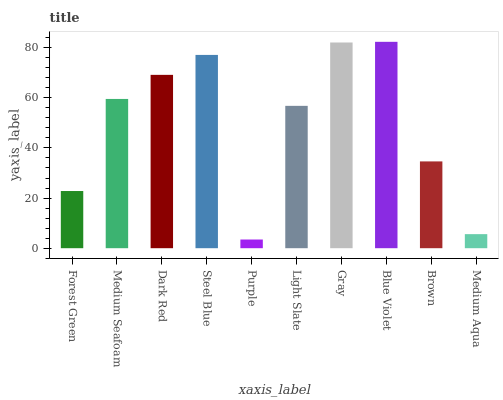Is Purple the minimum?
Answer yes or no. Yes. Is Blue Violet the maximum?
Answer yes or no. Yes. Is Medium Seafoam the minimum?
Answer yes or no. No. Is Medium Seafoam the maximum?
Answer yes or no. No. Is Medium Seafoam greater than Forest Green?
Answer yes or no. Yes. Is Forest Green less than Medium Seafoam?
Answer yes or no. Yes. Is Forest Green greater than Medium Seafoam?
Answer yes or no. No. Is Medium Seafoam less than Forest Green?
Answer yes or no. No. Is Medium Seafoam the high median?
Answer yes or no. Yes. Is Light Slate the low median?
Answer yes or no. Yes. Is Light Slate the high median?
Answer yes or no. No. Is Steel Blue the low median?
Answer yes or no. No. 